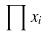<formula> <loc_0><loc_0><loc_500><loc_500>\prod x _ { i }</formula> 